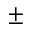<formula> <loc_0><loc_0><loc_500><loc_500>\pm</formula> 